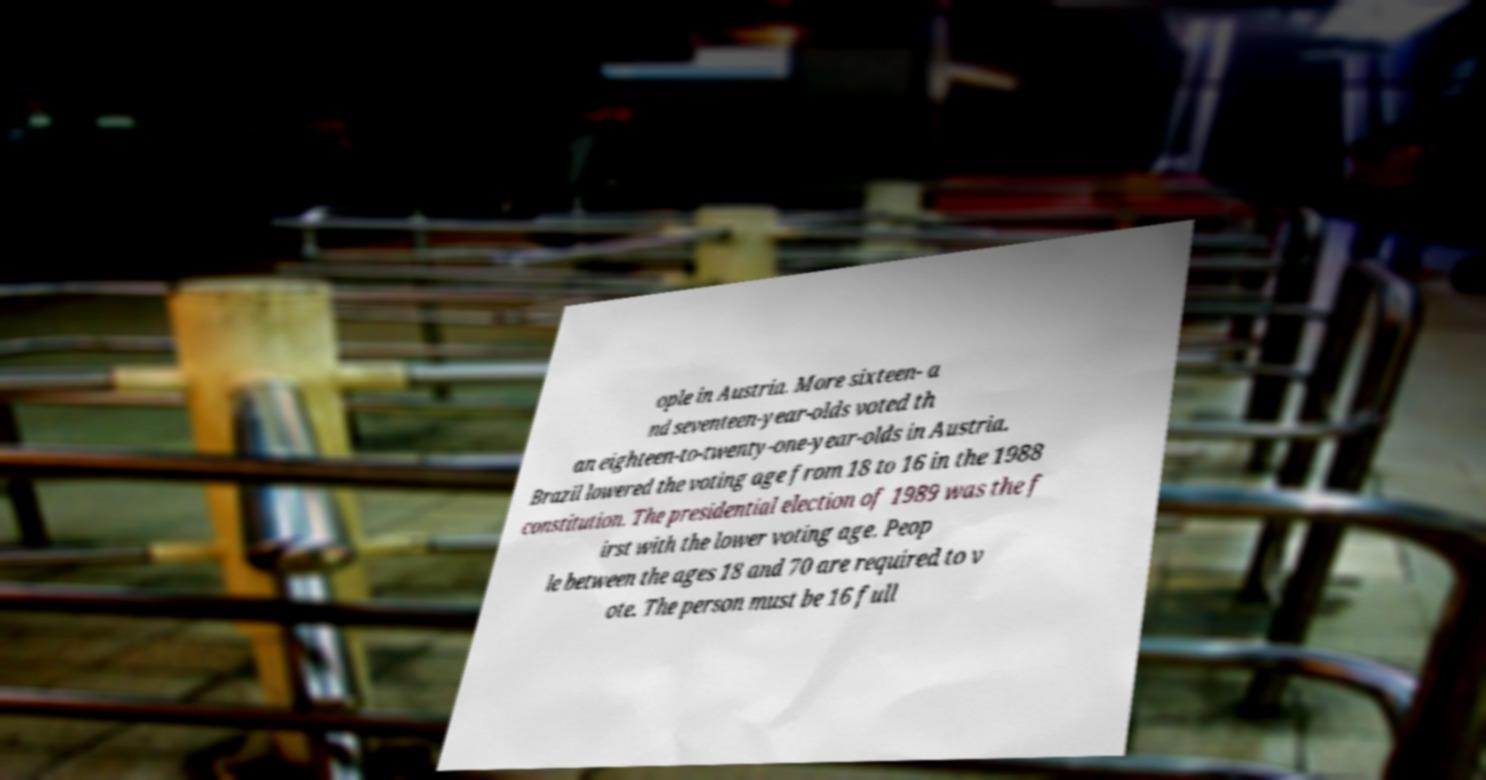There's text embedded in this image that I need extracted. Can you transcribe it verbatim? ople in Austria. More sixteen- a nd seventeen-year-olds voted th an eighteen-to-twenty-one-year-olds in Austria. Brazil lowered the voting age from 18 to 16 in the 1988 constitution. The presidential election of 1989 was the f irst with the lower voting age. Peop le between the ages 18 and 70 are required to v ote. The person must be 16 full 